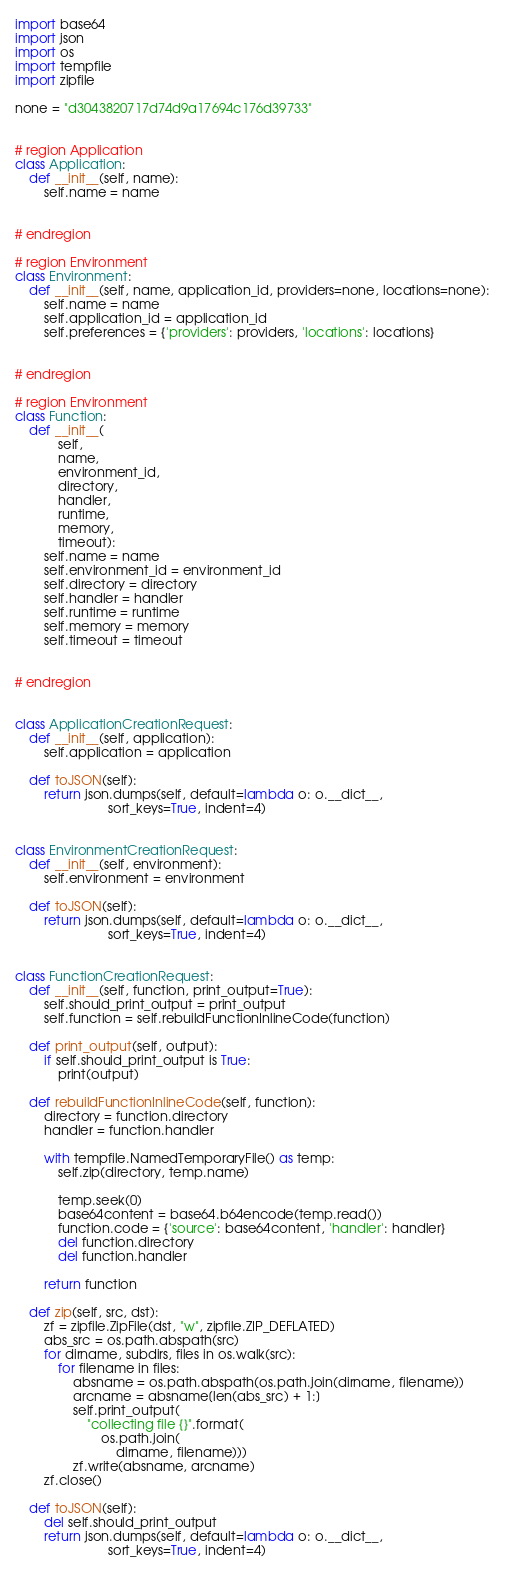<code> <loc_0><loc_0><loc_500><loc_500><_Python_>import base64
import json
import os
import tempfile
import zipfile

none = "d3043820717d74d9a17694c176d39733"


# region Application
class Application:
    def __init__(self, name):
        self.name = name


# endregion

# region Environment
class Environment:
    def __init__(self, name, application_id, providers=none, locations=none):
        self.name = name
        self.application_id = application_id
        self.preferences = {'providers': providers, 'locations': locations}


# endregion

# region Environment
class Function:
    def __init__(
            self,
            name,
            environment_id,
            directory,
            handler,
            runtime,
            memory,
            timeout):
        self.name = name
        self.environment_id = environment_id
        self.directory = directory
        self.handler = handler
        self.runtime = runtime
        self.memory = memory
        self.timeout = timeout


# endregion


class ApplicationCreationRequest:
    def __init__(self, application):
        self.application = application

    def toJSON(self):
        return json.dumps(self, default=lambda o: o.__dict__,
                          sort_keys=True, indent=4)


class EnvironmentCreationRequest:
    def __init__(self, environment):
        self.environment = environment

    def toJSON(self):
        return json.dumps(self, default=lambda o: o.__dict__,
                          sort_keys=True, indent=4)


class FunctionCreationRequest:
    def __init__(self, function, print_output=True):
        self.should_print_output = print_output
        self.function = self.rebuildFunctionInlineCode(function)

    def print_output(self, output):
        if self.should_print_output is True:
            print(output)

    def rebuildFunctionInlineCode(self, function):
        directory = function.directory
        handler = function.handler

        with tempfile.NamedTemporaryFile() as temp:
            self.zip(directory, temp.name)

            temp.seek(0)
            base64content = base64.b64encode(temp.read())
            function.code = {'source': base64content, 'handler': handler}
            del function.directory
            del function.handler

        return function

    def zip(self, src, dst):
        zf = zipfile.ZipFile(dst, "w", zipfile.ZIP_DEFLATED)
        abs_src = os.path.abspath(src)
        for dirname, subdirs, files in os.walk(src):
            for filename in files:
                absname = os.path.abspath(os.path.join(dirname, filename))
                arcname = absname[len(abs_src) + 1:]
                self.print_output(
                    "collecting file {}".format(
                        os.path.join(
                            dirname, filename)))
                zf.write(absname, arcname)
        zf.close()

    def toJSON(self):
        del self.should_print_output
        return json.dumps(self, default=lambda o: o.__dict__,
                          sort_keys=True, indent=4)
</code> 